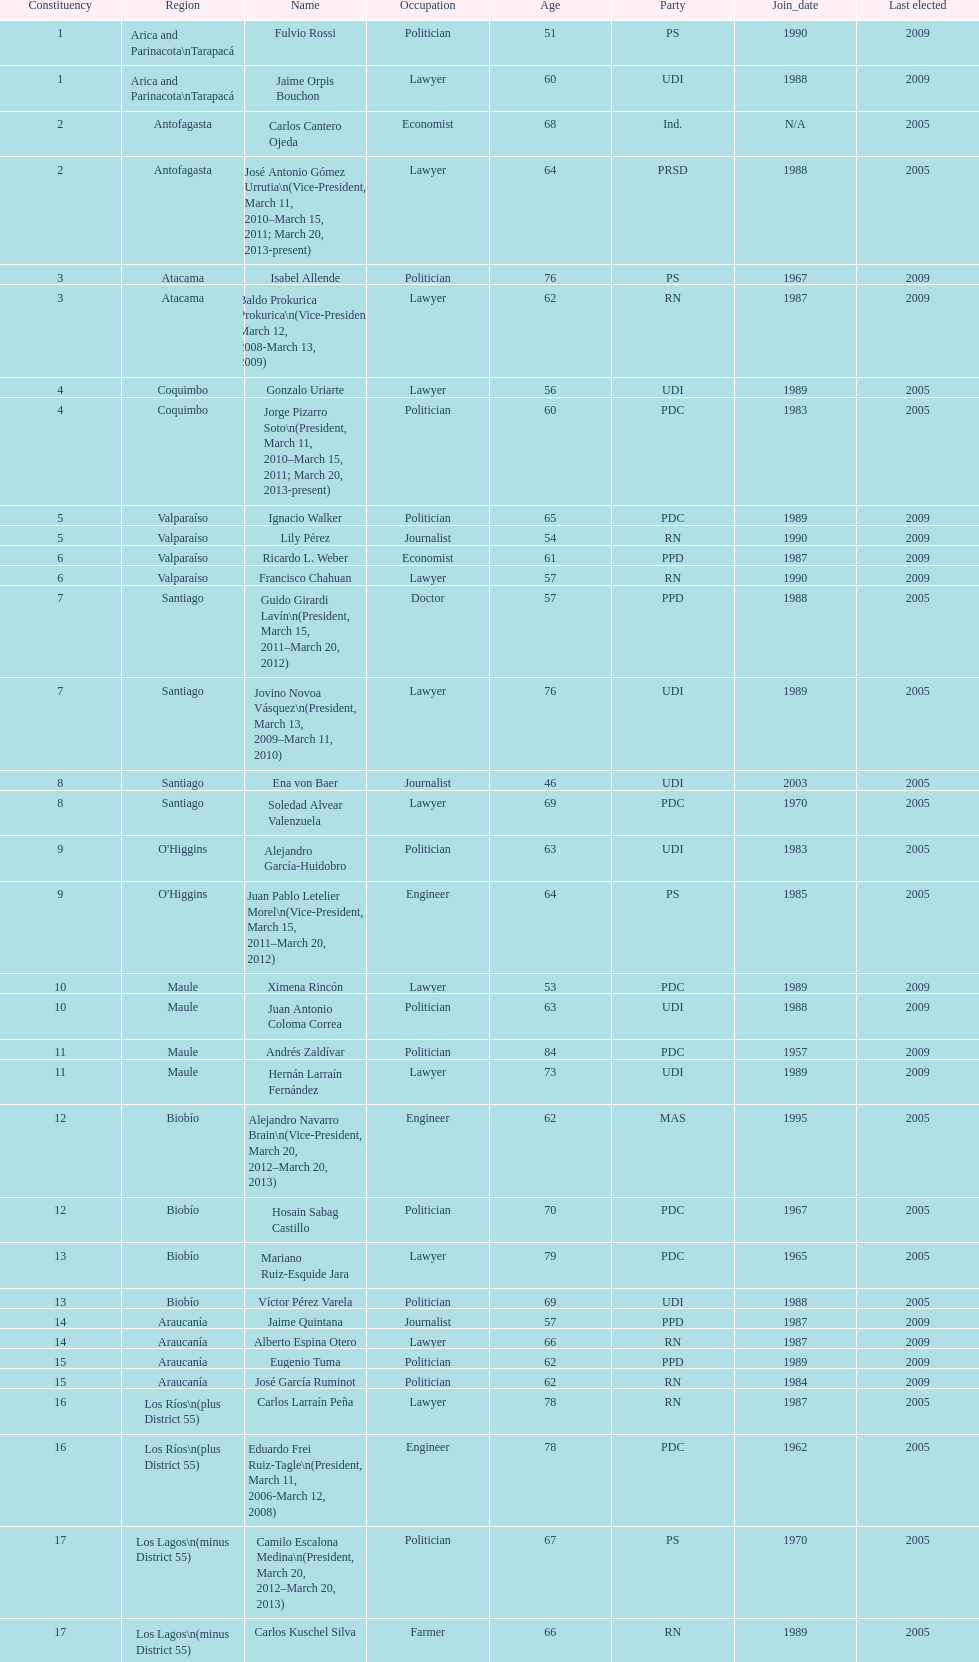What is the first name on the table? Fulvio Rossi. 